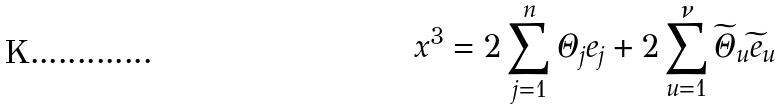<formula> <loc_0><loc_0><loc_500><loc_500>x ^ { 3 } = 2 \sum _ { j = 1 } ^ { n } \Theta _ { j } e _ { j } + 2 \sum _ { u = 1 } ^ { \nu } \widetilde { \Theta } _ { u } \widetilde { e } _ { u }</formula> 